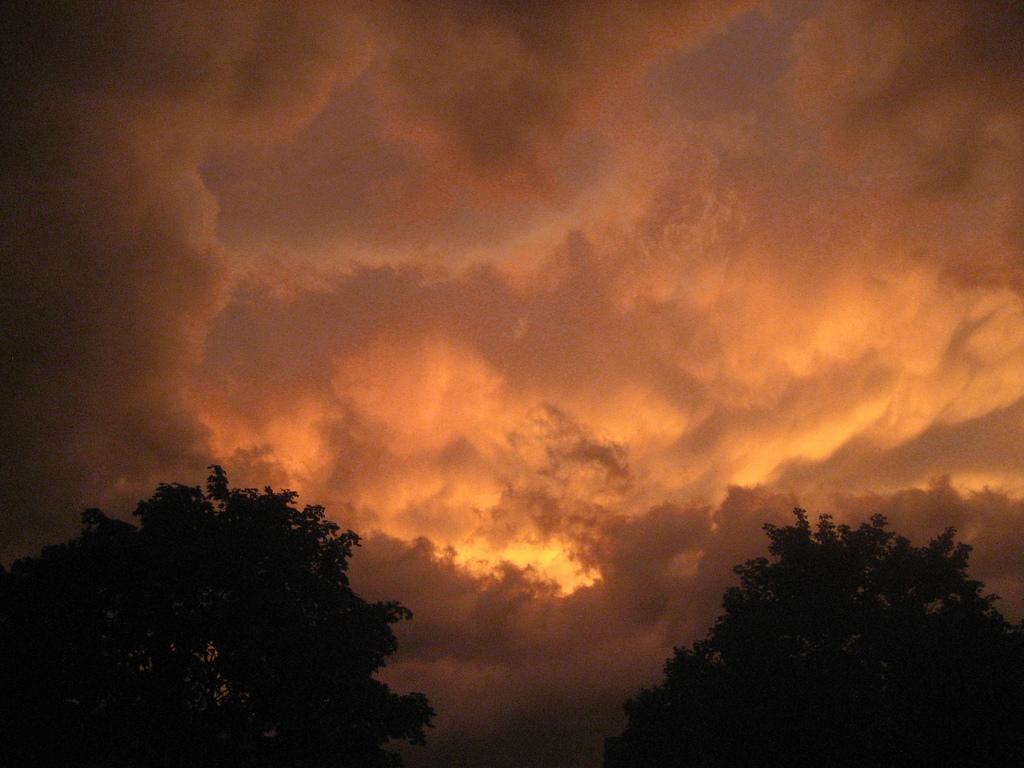How would you summarize this image in a sentence or two? In this image we can see trees and the sky with clouds. 